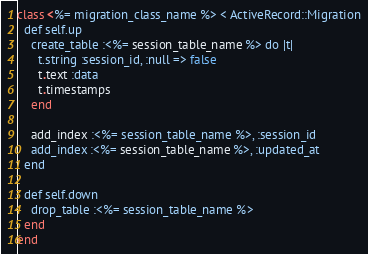Convert code to text. <code><loc_0><loc_0><loc_500><loc_500><_Ruby_>class <%= migration_class_name %> < ActiveRecord::Migration
  def self.up
    create_table :<%= session_table_name %> do |t|
      t.string :session_id, :null => false
      t.text :data
      t.timestamps
    end

    add_index :<%= session_table_name %>, :session_id
    add_index :<%= session_table_name %>, :updated_at
  end

  def self.down
    drop_table :<%= session_table_name %>
  end
end
</code> 